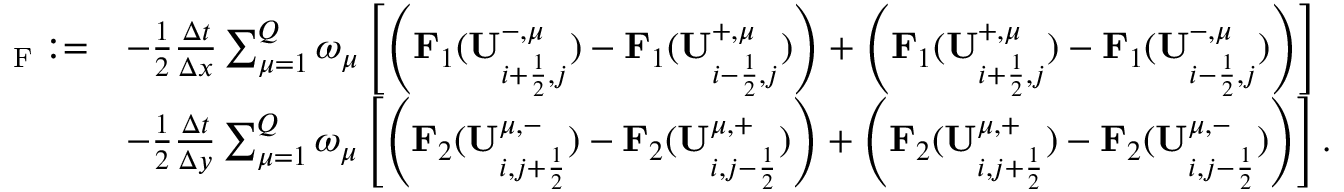Convert formula to latex. <formula><loc_0><loc_0><loc_500><loc_500>\begin{array} { r l } { { \Pi } _ { F } \colon = } & { - \frac { 1 } { 2 } \frac { \Delta t } { \Delta x } \sum _ { \mu = 1 } ^ { Q } \omega _ { \mu } \left [ \left ( F _ { 1 } ( U _ { i + \frac { 1 } { 2 } , j } ^ { - , \mu } ) - F _ { 1 } ( U _ { i - \frac { 1 } { 2 } , j } ^ { + , \mu } ) \right ) + \left ( F _ { 1 } ( U _ { i + \frac { 1 } { 2 } , j } ^ { + , \mu } ) - F _ { 1 } ( U _ { i - \frac { 1 } { 2 } , j } ^ { - , \mu } ) \right ) \right ] } \\ & { - \frac { 1 } { 2 } \frac { \Delta t } { \Delta y } \sum _ { \mu = 1 } ^ { Q } \omega _ { \mu } \left [ \left ( F _ { 2 } ( U _ { i , j + \frac { 1 } { 2 } } ^ { \mu , - } ) - F _ { 2 } ( U _ { i , j - \frac { 1 } { 2 } } ^ { \mu , + } ) \right ) + \left ( F _ { 2 } ( U _ { i , j + \frac { 1 } { 2 } } ^ { \mu , + } ) - F _ { 2 } ( U _ { i , j - \frac { 1 } { 2 } } ^ { \mu , - } ) \right ) \right ] . } \end{array}</formula> 